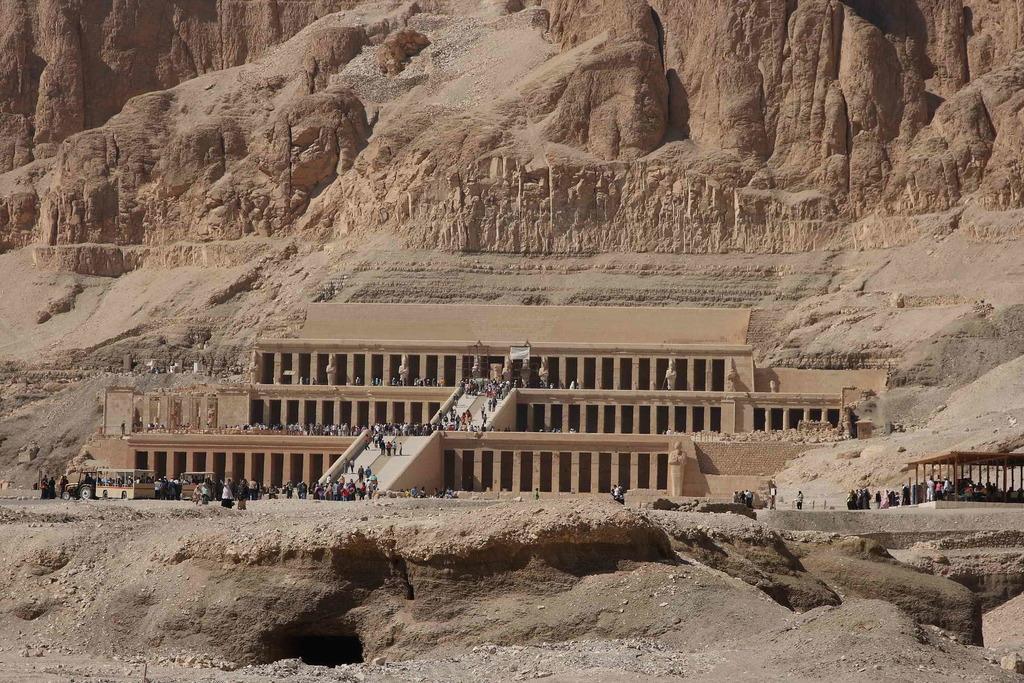Can you describe this image briefly? In this image I can see the hill and I can see building , in front of the building I can see persons and vehicles. 